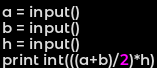Convert code to text. <code><loc_0><loc_0><loc_500><loc_500><_Python_>a = input()
b = input()
h = input()
print int(((a+b)/2)*h)</code> 